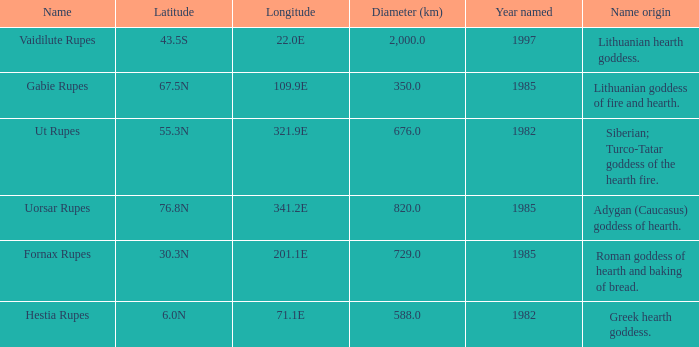At a latitude of 71.1e, what is the feature's name origin? Greek hearth goddess. 